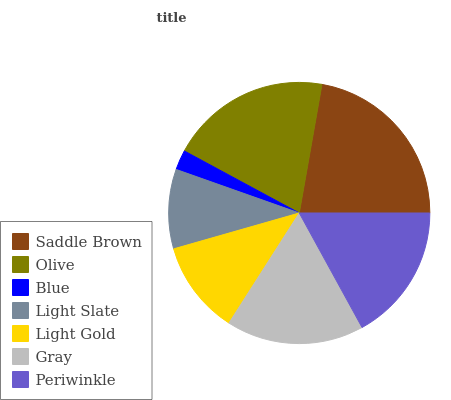Is Blue the minimum?
Answer yes or no. Yes. Is Saddle Brown the maximum?
Answer yes or no. Yes. Is Olive the minimum?
Answer yes or no. No. Is Olive the maximum?
Answer yes or no. No. Is Saddle Brown greater than Olive?
Answer yes or no. Yes. Is Olive less than Saddle Brown?
Answer yes or no. Yes. Is Olive greater than Saddle Brown?
Answer yes or no. No. Is Saddle Brown less than Olive?
Answer yes or no. No. Is Periwinkle the high median?
Answer yes or no. Yes. Is Periwinkle the low median?
Answer yes or no. Yes. Is Light Gold the high median?
Answer yes or no. No. Is Saddle Brown the low median?
Answer yes or no. No. 